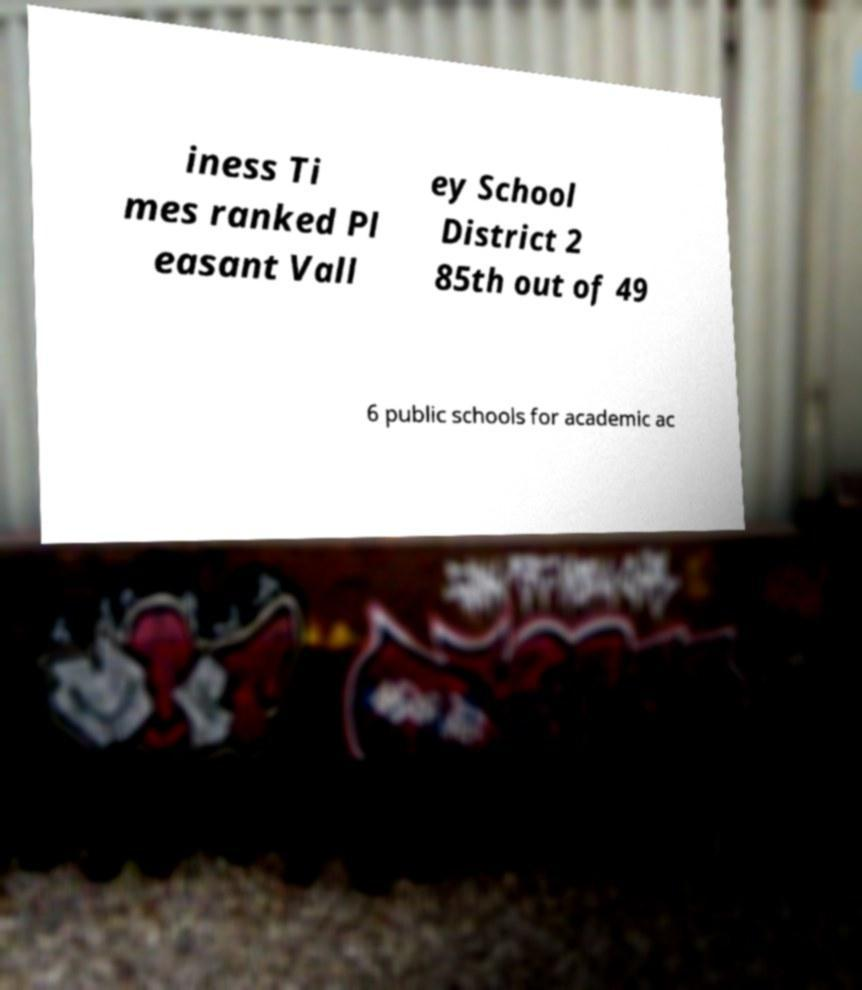There's text embedded in this image that I need extracted. Can you transcribe it verbatim? iness Ti mes ranked Pl easant Vall ey School District 2 85th out of 49 6 public schools for academic ac 